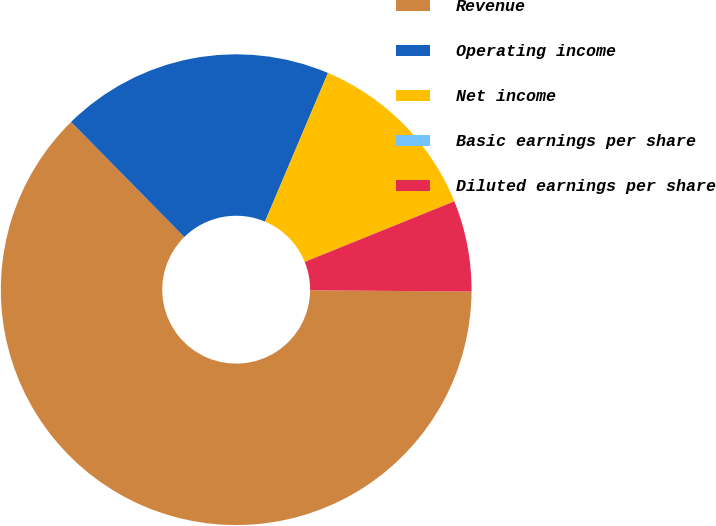Convert chart to OTSL. <chart><loc_0><loc_0><loc_500><loc_500><pie_chart><fcel>Revenue<fcel>Operating income<fcel>Net income<fcel>Basic earnings per share<fcel>Diluted earnings per share<nl><fcel>62.5%<fcel>18.75%<fcel>12.5%<fcel>0.0%<fcel>6.25%<nl></chart> 